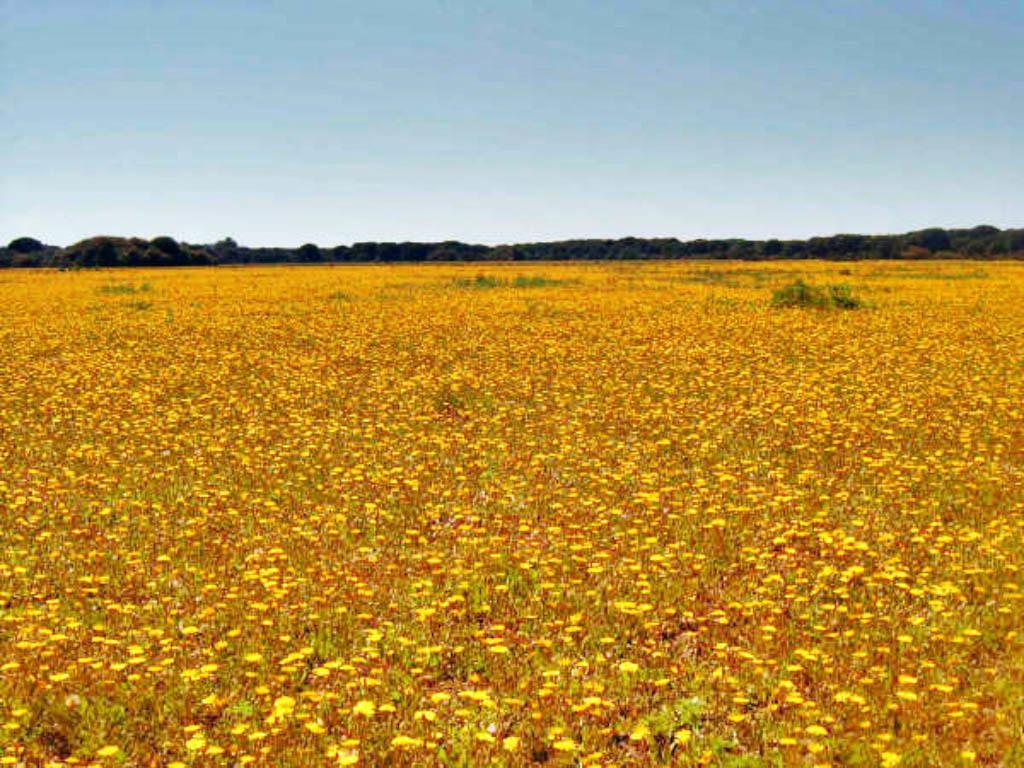Please provide a concise description of this image. In this image we can see an agricultural field, trees and sky. 